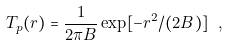Convert formula to latex. <formula><loc_0><loc_0><loc_500><loc_500>T _ { p } ( r ) = \frac { 1 } { 2 \pi B } \exp [ - r ^ { 2 } / ( 2 B ) ] \ ,</formula> 